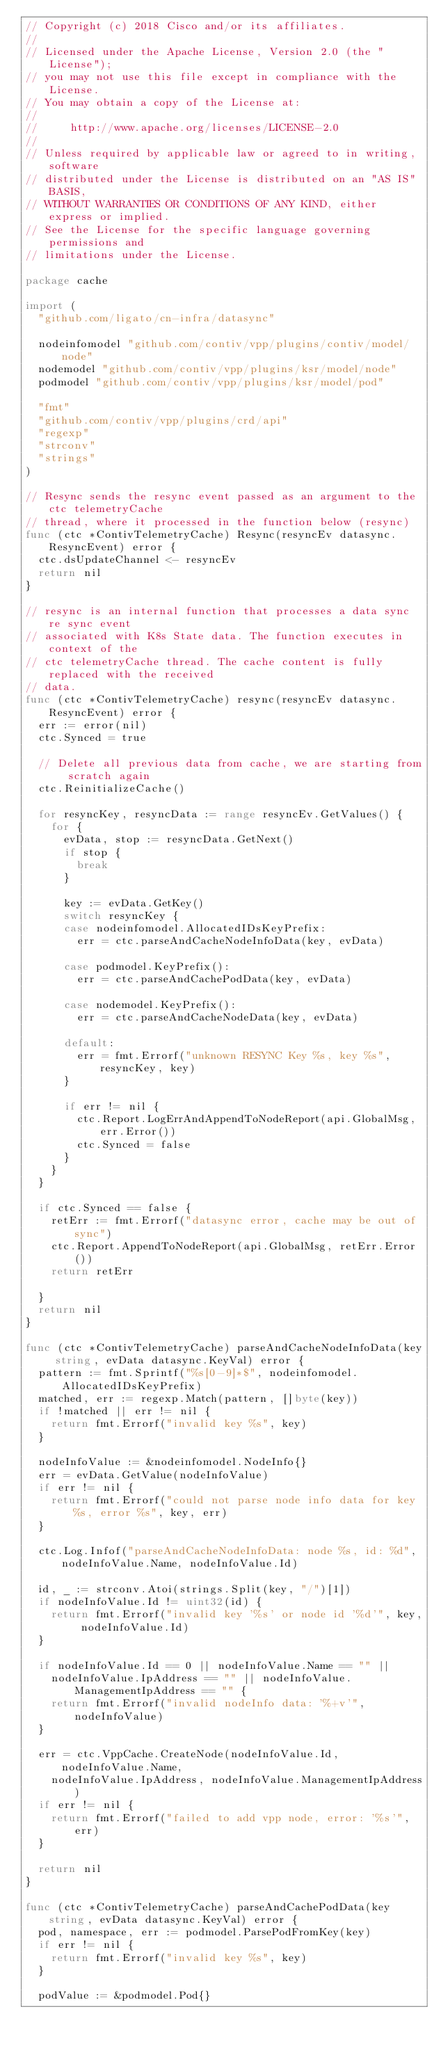Convert code to text. <code><loc_0><loc_0><loc_500><loc_500><_Go_>// Copyright (c) 2018 Cisco and/or its affiliates.
//
// Licensed under the Apache License, Version 2.0 (the "License");
// you may not use this file except in compliance with the License.
// You may obtain a copy of the License at:
//
//     http://www.apache.org/licenses/LICENSE-2.0
//
// Unless required by applicable law or agreed to in writing, software
// distributed under the License is distributed on an "AS IS" BASIS,
// WITHOUT WARRANTIES OR CONDITIONS OF ANY KIND, either express or implied.
// See the License for the specific language governing permissions and
// limitations under the License.

package cache

import (
	"github.com/ligato/cn-infra/datasync"

	nodeinfomodel "github.com/contiv/vpp/plugins/contiv/model/node"
	nodemodel "github.com/contiv/vpp/plugins/ksr/model/node"
	podmodel "github.com/contiv/vpp/plugins/ksr/model/pod"

	"fmt"
	"github.com/contiv/vpp/plugins/crd/api"
	"regexp"
	"strconv"
	"strings"
)

// Resync sends the resync event passed as an argument to the ctc telemetryCache
// thread, where it processed in the function below (resync)
func (ctc *ContivTelemetryCache) Resync(resyncEv datasync.ResyncEvent) error {
	ctc.dsUpdateChannel <- resyncEv
	return nil
}

// resync is an internal function that processes a data sync re sync event
// associated with K8s State data. The function executes in context of the
// ctc telemetryCache thread. The cache content is fully replaced with the received
// data.
func (ctc *ContivTelemetryCache) resync(resyncEv datasync.ResyncEvent) error {
	err := error(nil)
	ctc.Synced = true

	// Delete all previous data from cache, we are starting from scratch again
	ctc.ReinitializeCache()

	for resyncKey, resyncData := range resyncEv.GetValues() {
		for {
			evData, stop := resyncData.GetNext()
			if stop {
				break
			}

			key := evData.GetKey()
			switch resyncKey {
			case nodeinfomodel.AllocatedIDsKeyPrefix:
				err = ctc.parseAndCacheNodeInfoData(key, evData)

			case podmodel.KeyPrefix():
				err = ctc.parseAndCachePodData(key, evData)

			case nodemodel.KeyPrefix():
				err = ctc.parseAndCacheNodeData(key, evData)

			default:
				err = fmt.Errorf("unknown RESYNC Key %s, key %s", resyncKey, key)
			}

			if err != nil {
				ctc.Report.LogErrAndAppendToNodeReport(api.GlobalMsg, err.Error())
				ctc.Synced = false
			}
		}
	}

	if ctc.Synced == false {
		retErr := fmt.Errorf("datasync error, cache may be out of sync")
		ctc.Report.AppendToNodeReport(api.GlobalMsg, retErr.Error())
		return retErr

	}
	return nil
}

func (ctc *ContivTelemetryCache) parseAndCacheNodeInfoData(key string, evData datasync.KeyVal) error {
	pattern := fmt.Sprintf("%s[0-9]*$", nodeinfomodel.AllocatedIDsKeyPrefix)
	matched, err := regexp.Match(pattern, []byte(key))
	if !matched || err != nil {
		return fmt.Errorf("invalid key %s", key)
	}

	nodeInfoValue := &nodeinfomodel.NodeInfo{}
	err = evData.GetValue(nodeInfoValue)
	if err != nil {
		return fmt.Errorf("could not parse node info data for key %s, error %s", key, err)
	}

	ctc.Log.Infof("parseAndCacheNodeInfoData: node %s, id: %d", nodeInfoValue.Name, nodeInfoValue.Id)

	id, _ := strconv.Atoi(strings.Split(key, "/")[1])
	if nodeInfoValue.Id != uint32(id) {
		return fmt.Errorf("invalid key '%s' or node id '%d'", key, nodeInfoValue.Id)
	}

	if nodeInfoValue.Id == 0 || nodeInfoValue.Name == "" ||
		nodeInfoValue.IpAddress == "" || nodeInfoValue.ManagementIpAddress == "" {
		return fmt.Errorf("invalid nodeInfo data: '%+v'", nodeInfoValue)
	}

	err = ctc.VppCache.CreateNode(nodeInfoValue.Id, nodeInfoValue.Name,
		nodeInfoValue.IpAddress, nodeInfoValue.ManagementIpAddress)
	if err != nil {
		return fmt.Errorf("failed to add vpp node, error: '%s'", err)
	}

	return nil
}

func (ctc *ContivTelemetryCache) parseAndCachePodData(key string, evData datasync.KeyVal) error {
	pod, namespace, err := podmodel.ParsePodFromKey(key)
	if err != nil {
		return fmt.Errorf("invalid key %s", key)
	}

	podValue := &podmodel.Pod{}</code> 